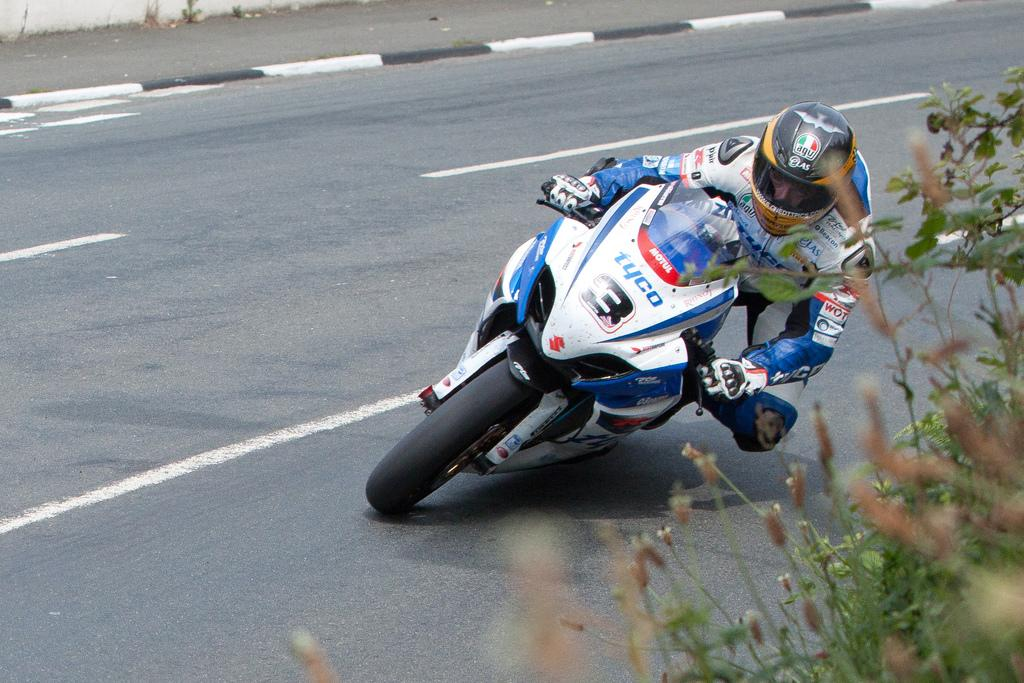What is the person in the image doing? The person is riding a bike in the image. What is the person wearing while riding the bike? The person is wearing a helmet. Where is the bike located in the image? The bike is on the road. What can be seen on the bike? There is text on the bike. What is visible on the right side of the image? There are plants on the right side of the image. What type of cherry is the person eating while riding the bike in the image? There is no cherry present in the image; the person is wearing a helmet and riding a bike. How does the person's anger affect their ability to ride the bike in the image? There is no indication of the person's emotions in the image, and their ability to ride the bike is not affected by any emotions. 